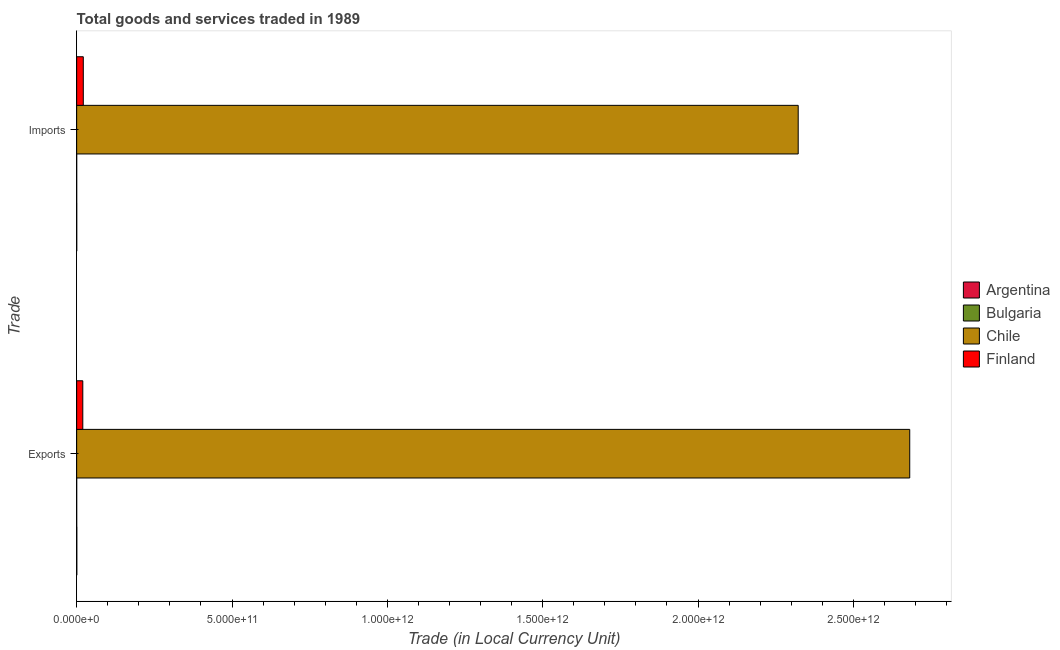How many groups of bars are there?
Make the answer very short. 2. Are the number of bars per tick equal to the number of legend labels?
Your answer should be compact. Yes. Are the number of bars on each tick of the Y-axis equal?
Provide a short and direct response. Yes. How many bars are there on the 1st tick from the top?
Give a very brief answer. 4. How many bars are there on the 1st tick from the bottom?
Your answer should be very brief. 4. What is the label of the 2nd group of bars from the top?
Give a very brief answer. Exports. What is the imports of goods and services in Chile?
Your answer should be compact. 2.32e+12. Across all countries, what is the maximum imports of goods and services?
Your answer should be very brief. 2.32e+12. Across all countries, what is the minimum imports of goods and services?
Ensure brevity in your answer.  1.91e+07. What is the total export of goods and services in the graph?
Keep it short and to the point. 2.70e+12. What is the difference between the imports of goods and services in Finland and that in Chile?
Provide a short and direct response. -2.30e+12. What is the difference between the imports of goods and services in Bulgaria and the export of goods and services in Finland?
Your response must be concise. -1.98e+1. What is the average imports of goods and services per country?
Provide a short and direct response. 5.86e+11. What is the difference between the export of goods and services and imports of goods and services in Bulgaria?
Ensure brevity in your answer.  -6.88e+05. In how many countries, is the export of goods and services greater than 700000000000 LCU?
Your response must be concise. 1. What is the ratio of the export of goods and services in Bulgaria to that in Finland?
Your response must be concise. 0. Is the export of goods and services in Argentina less than that in Chile?
Offer a terse response. Yes. What does the 1st bar from the top in Exports represents?
Offer a terse response. Finland. How many bars are there?
Offer a terse response. 8. Are all the bars in the graph horizontal?
Your answer should be compact. Yes. How many countries are there in the graph?
Give a very brief answer. 4. What is the difference between two consecutive major ticks on the X-axis?
Give a very brief answer. 5.00e+11. Does the graph contain grids?
Provide a short and direct response. No. What is the title of the graph?
Offer a very short reply. Total goods and services traded in 1989. What is the label or title of the X-axis?
Provide a short and direct response. Trade (in Local Currency Unit). What is the label or title of the Y-axis?
Keep it short and to the point. Trade. What is the Trade (in Local Currency Unit) of Argentina in Exports?
Offer a terse response. 4.24e+08. What is the Trade (in Local Currency Unit) of Bulgaria in Exports?
Offer a terse response. 1.84e+07. What is the Trade (in Local Currency Unit) in Chile in Exports?
Your response must be concise. 2.68e+12. What is the Trade (in Local Currency Unit) of Finland in Exports?
Your response must be concise. 1.98e+1. What is the Trade (in Local Currency Unit) of Argentina in Imports?
Your answer should be compact. 2.13e+08. What is the Trade (in Local Currency Unit) in Bulgaria in Imports?
Your response must be concise. 1.91e+07. What is the Trade (in Local Currency Unit) in Chile in Imports?
Offer a very short reply. 2.32e+12. What is the Trade (in Local Currency Unit) of Finland in Imports?
Offer a very short reply. 2.13e+1. Across all Trade, what is the maximum Trade (in Local Currency Unit) in Argentina?
Offer a terse response. 4.24e+08. Across all Trade, what is the maximum Trade (in Local Currency Unit) of Bulgaria?
Ensure brevity in your answer.  1.91e+07. Across all Trade, what is the maximum Trade (in Local Currency Unit) in Chile?
Give a very brief answer. 2.68e+12. Across all Trade, what is the maximum Trade (in Local Currency Unit) of Finland?
Make the answer very short. 2.13e+1. Across all Trade, what is the minimum Trade (in Local Currency Unit) in Argentina?
Provide a short and direct response. 2.13e+08. Across all Trade, what is the minimum Trade (in Local Currency Unit) of Bulgaria?
Offer a terse response. 1.84e+07. Across all Trade, what is the minimum Trade (in Local Currency Unit) in Chile?
Your answer should be compact. 2.32e+12. Across all Trade, what is the minimum Trade (in Local Currency Unit) of Finland?
Keep it short and to the point. 1.98e+1. What is the total Trade (in Local Currency Unit) in Argentina in the graph?
Ensure brevity in your answer.  6.37e+08. What is the total Trade (in Local Currency Unit) in Bulgaria in the graph?
Your answer should be very brief. 3.74e+07. What is the total Trade (in Local Currency Unit) of Chile in the graph?
Your answer should be very brief. 5.00e+12. What is the total Trade (in Local Currency Unit) in Finland in the graph?
Provide a short and direct response. 4.11e+1. What is the difference between the Trade (in Local Currency Unit) in Argentina in Exports and that in Imports?
Your answer should be very brief. 2.10e+08. What is the difference between the Trade (in Local Currency Unit) of Bulgaria in Exports and that in Imports?
Your response must be concise. -6.88e+05. What is the difference between the Trade (in Local Currency Unit) of Chile in Exports and that in Imports?
Your response must be concise. 3.59e+11. What is the difference between the Trade (in Local Currency Unit) in Finland in Exports and that in Imports?
Make the answer very short. -1.57e+09. What is the difference between the Trade (in Local Currency Unit) of Argentina in Exports and the Trade (in Local Currency Unit) of Bulgaria in Imports?
Make the answer very short. 4.05e+08. What is the difference between the Trade (in Local Currency Unit) of Argentina in Exports and the Trade (in Local Currency Unit) of Chile in Imports?
Keep it short and to the point. -2.32e+12. What is the difference between the Trade (in Local Currency Unit) in Argentina in Exports and the Trade (in Local Currency Unit) in Finland in Imports?
Your response must be concise. -2.09e+1. What is the difference between the Trade (in Local Currency Unit) in Bulgaria in Exports and the Trade (in Local Currency Unit) in Chile in Imports?
Your response must be concise. -2.32e+12. What is the difference between the Trade (in Local Currency Unit) in Bulgaria in Exports and the Trade (in Local Currency Unit) in Finland in Imports?
Give a very brief answer. -2.13e+1. What is the difference between the Trade (in Local Currency Unit) in Chile in Exports and the Trade (in Local Currency Unit) in Finland in Imports?
Your answer should be compact. 2.66e+12. What is the average Trade (in Local Currency Unit) in Argentina per Trade?
Provide a succinct answer. 3.19e+08. What is the average Trade (in Local Currency Unit) in Bulgaria per Trade?
Provide a short and direct response. 1.87e+07. What is the average Trade (in Local Currency Unit) in Chile per Trade?
Your answer should be very brief. 2.50e+12. What is the average Trade (in Local Currency Unit) of Finland per Trade?
Make the answer very short. 2.06e+1. What is the difference between the Trade (in Local Currency Unit) of Argentina and Trade (in Local Currency Unit) of Bulgaria in Exports?
Offer a very short reply. 4.05e+08. What is the difference between the Trade (in Local Currency Unit) of Argentina and Trade (in Local Currency Unit) of Chile in Exports?
Provide a succinct answer. -2.68e+12. What is the difference between the Trade (in Local Currency Unit) of Argentina and Trade (in Local Currency Unit) of Finland in Exports?
Keep it short and to the point. -1.94e+1. What is the difference between the Trade (in Local Currency Unit) in Bulgaria and Trade (in Local Currency Unit) in Chile in Exports?
Provide a succinct answer. -2.68e+12. What is the difference between the Trade (in Local Currency Unit) of Bulgaria and Trade (in Local Currency Unit) of Finland in Exports?
Your answer should be very brief. -1.98e+1. What is the difference between the Trade (in Local Currency Unit) in Chile and Trade (in Local Currency Unit) in Finland in Exports?
Offer a terse response. 2.66e+12. What is the difference between the Trade (in Local Currency Unit) of Argentina and Trade (in Local Currency Unit) of Bulgaria in Imports?
Provide a short and direct response. 1.94e+08. What is the difference between the Trade (in Local Currency Unit) of Argentina and Trade (in Local Currency Unit) of Chile in Imports?
Provide a short and direct response. -2.32e+12. What is the difference between the Trade (in Local Currency Unit) in Argentina and Trade (in Local Currency Unit) in Finland in Imports?
Your answer should be compact. -2.11e+1. What is the difference between the Trade (in Local Currency Unit) of Bulgaria and Trade (in Local Currency Unit) of Chile in Imports?
Offer a terse response. -2.32e+12. What is the difference between the Trade (in Local Currency Unit) in Bulgaria and Trade (in Local Currency Unit) in Finland in Imports?
Your response must be concise. -2.13e+1. What is the difference between the Trade (in Local Currency Unit) in Chile and Trade (in Local Currency Unit) in Finland in Imports?
Ensure brevity in your answer.  2.30e+12. What is the ratio of the Trade (in Local Currency Unit) in Argentina in Exports to that in Imports?
Your response must be concise. 1.98. What is the ratio of the Trade (in Local Currency Unit) in Bulgaria in Exports to that in Imports?
Keep it short and to the point. 0.96. What is the ratio of the Trade (in Local Currency Unit) of Chile in Exports to that in Imports?
Give a very brief answer. 1.15. What is the ratio of the Trade (in Local Currency Unit) of Finland in Exports to that in Imports?
Your answer should be very brief. 0.93. What is the difference between the highest and the second highest Trade (in Local Currency Unit) of Argentina?
Offer a very short reply. 2.10e+08. What is the difference between the highest and the second highest Trade (in Local Currency Unit) of Bulgaria?
Give a very brief answer. 6.88e+05. What is the difference between the highest and the second highest Trade (in Local Currency Unit) in Chile?
Ensure brevity in your answer.  3.59e+11. What is the difference between the highest and the second highest Trade (in Local Currency Unit) in Finland?
Your response must be concise. 1.57e+09. What is the difference between the highest and the lowest Trade (in Local Currency Unit) in Argentina?
Make the answer very short. 2.10e+08. What is the difference between the highest and the lowest Trade (in Local Currency Unit) in Bulgaria?
Ensure brevity in your answer.  6.88e+05. What is the difference between the highest and the lowest Trade (in Local Currency Unit) of Chile?
Offer a terse response. 3.59e+11. What is the difference between the highest and the lowest Trade (in Local Currency Unit) in Finland?
Give a very brief answer. 1.57e+09. 